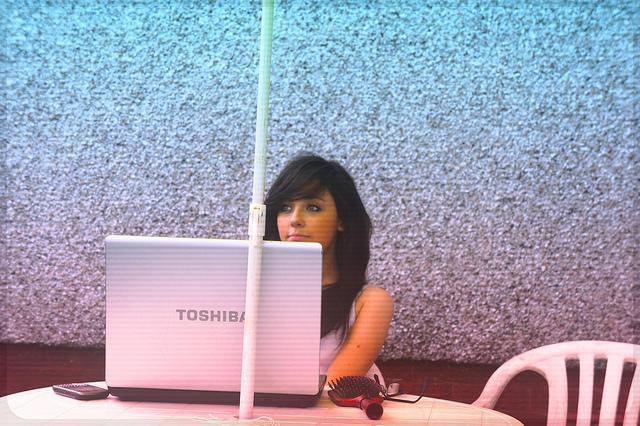How many dining tables can be seen?
Give a very brief answer. 1. 